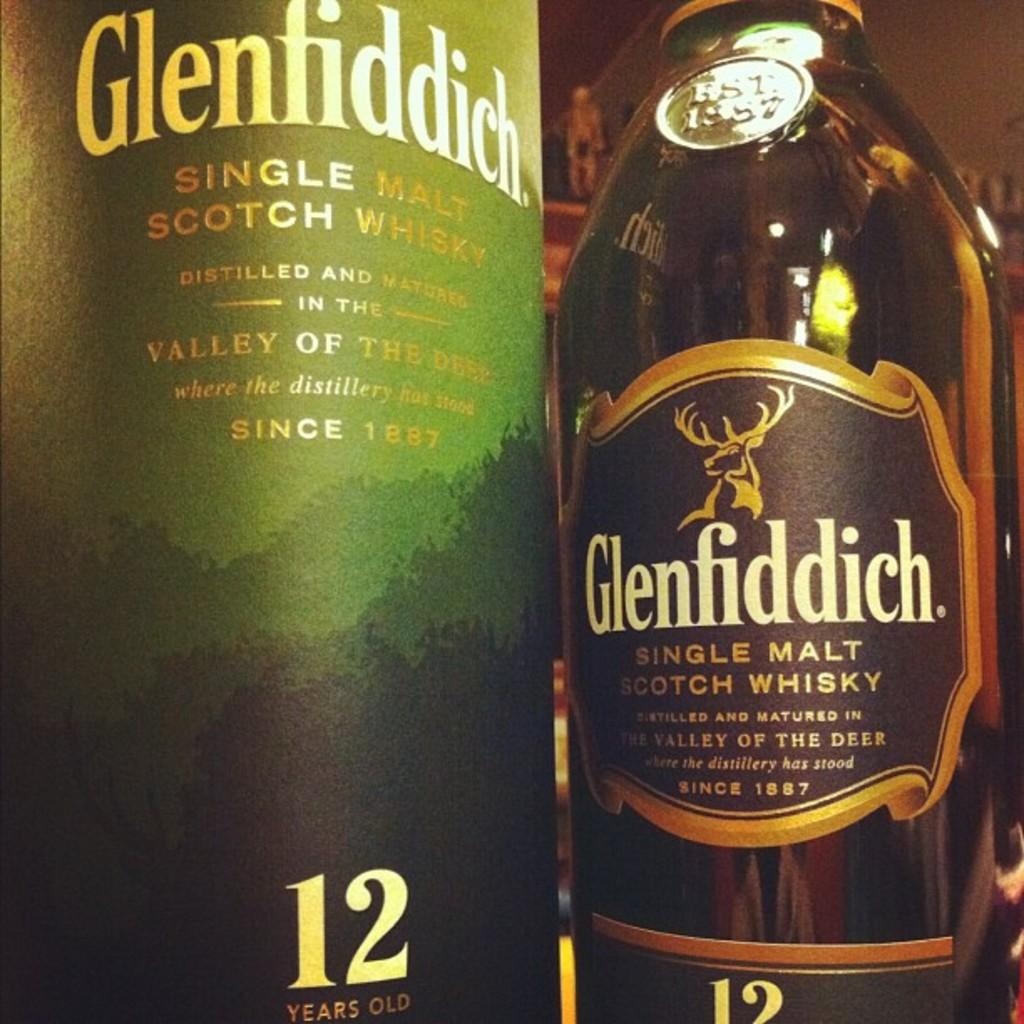<image>
Provide a brief description of the given image. A bottle of single malt Glenfiddich has been placed beside the green box it came in. 